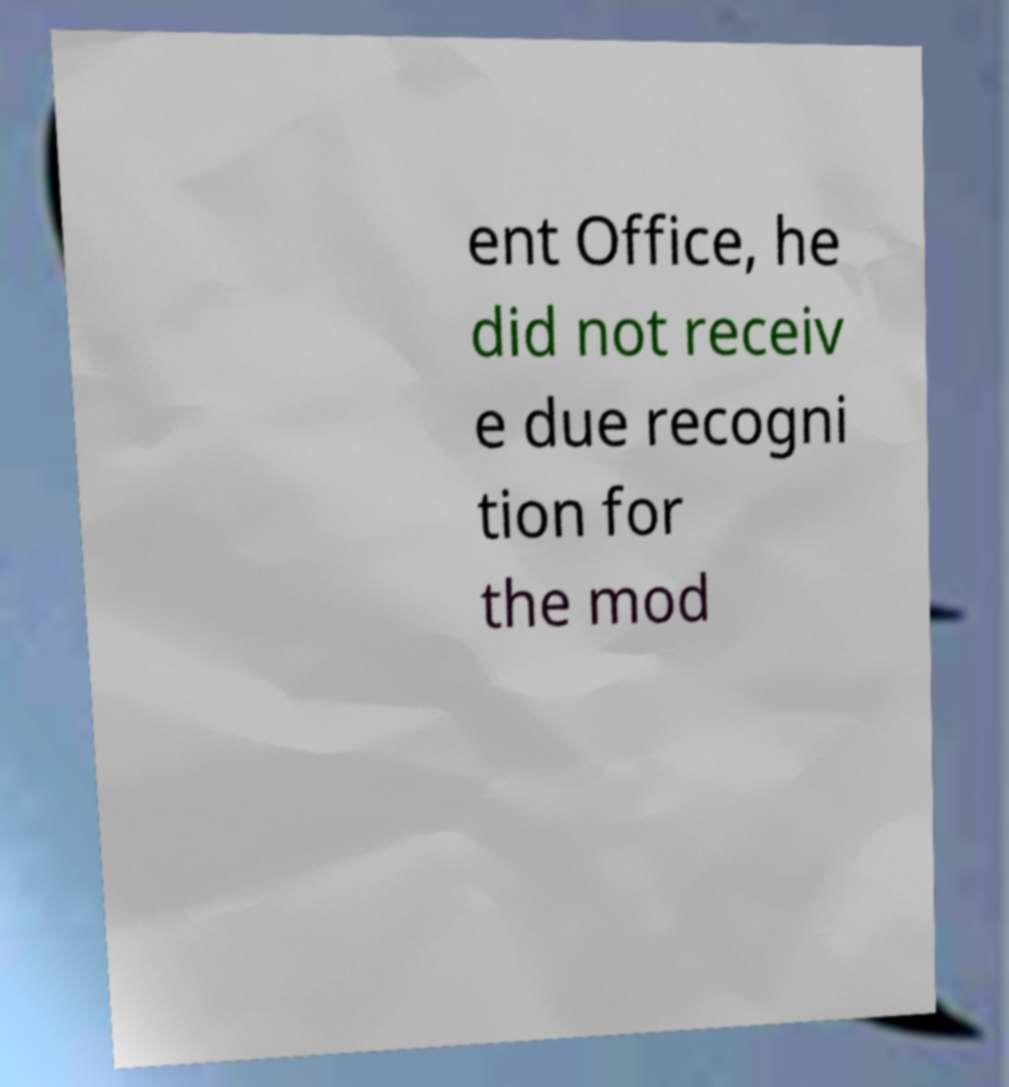There's text embedded in this image that I need extracted. Can you transcribe it verbatim? ent Office, he did not receiv e due recogni tion for the mod 